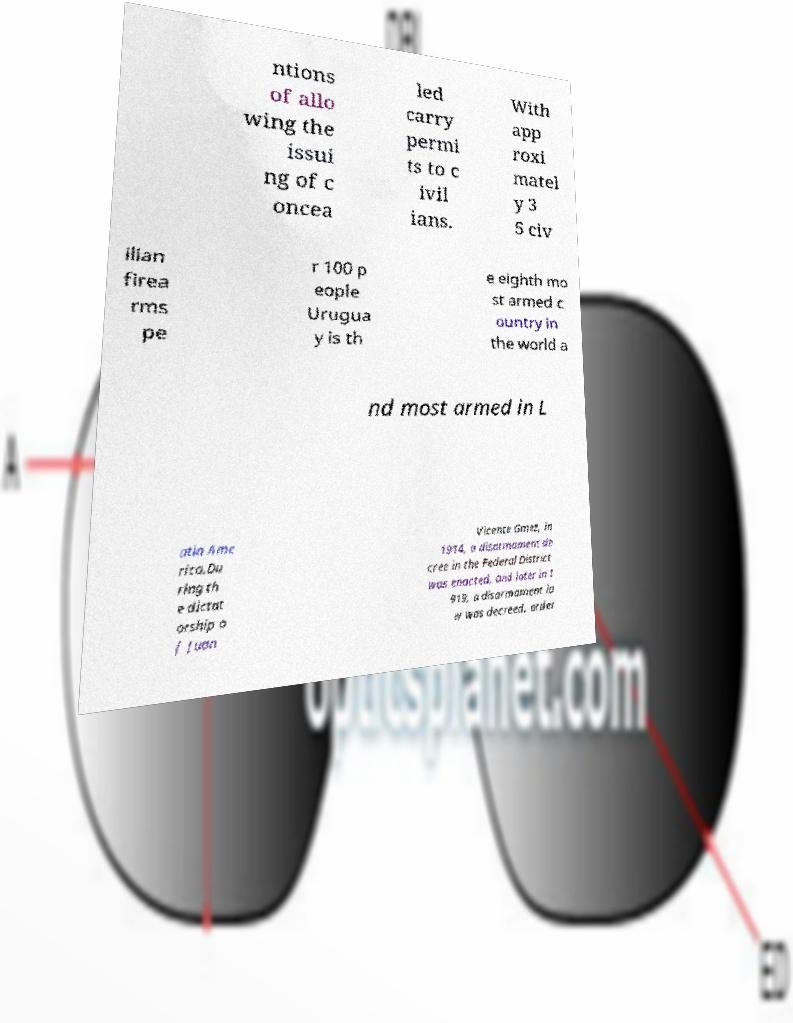Can you accurately transcribe the text from the provided image for me? ntions of allo wing the issui ng of c oncea led carry permi ts to c ivil ians. With app roxi matel y 3 5 civ ilian firea rms pe r 100 p eople Urugua y is th e eighth mo st armed c ountry in the world a nd most armed in L atin Ame rica.Du ring th e dictat orship o f Juan Vicente Gmez, in 1914, a disarmament de cree in the Federal District was enacted, and later in 1 919, a disarmament la w was decreed, order 